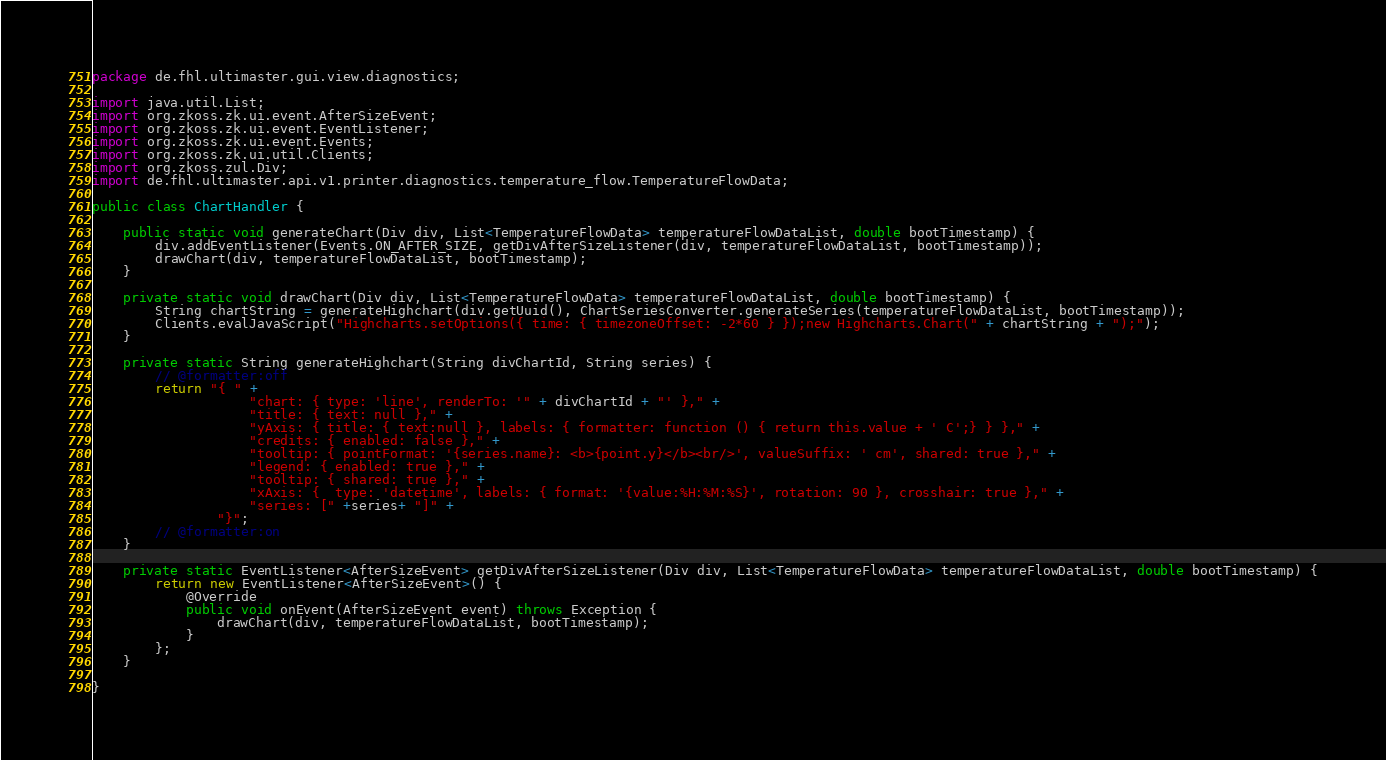Convert code to text. <code><loc_0><loc_0><loc_500><loc_500><_Java_>package de.fhl.ultimaster.gui.view.diagnostics;

import java.util.List;
import org.zkoss.zk.ui.event.AfterSizeEvent;
import org.zkoss.zk.ui.event.EventListener;
import org.zkoss.zk.ui.event.Events;
import org.zkoss.zk.ui.util.Clients;
import org.zkoss.zul.Div;
import de.fhl.ultimaster.api.v1.printer.diagnostics.temperature_flow.TemperatureFlowData;

public class ChartHandler {

    public static void generateChart(Div div, List<TemperatureFlowData> temperatureFlowDataList, double bootTimestamp) {
        div.addEventListener(Events.ON_AFTER_SIZE, getDivAfterSizeListener(div, temperatureFlowDataList, bootTimestamp));
        drawChart(div, temperatureFlowDataList, bootTimestamp);
    }

    private static void drawChart(Div div, List<TemperatureFlowData> temperatureFlowDataList, double bootTimestamp) {
        String chartString = generateHighchart(div.getUuid(), ChartSeriesConverter.generateSeries(temperatureFlowDataList, bootTimestamp));
        Clients.evalJavaScript("Highcharts.setOptions({ time: { timezoneOffset: -2*60 } });new Highcharts.Chart(" + chartString + ");");
    }

    private static String generateHighchart(String divChartId, String series) {
        // @formatter:off
        return "{ " +
                    "chart: { type: 'line', renderTo: '" + divChartId + "' }," +
                    "title: { text: null }," +
                    "yAxis: { title: { text:null }, labels: { formatter: function () { return this.value + ' C';} } }," +
                    "credits: { enabled: false }," +
                    "tooltip: { pointFormat: '{series.name}: <b>{point.y}</b><br/>', valueSuffix: ' cm', shared: true }," +
                    "legend: { enabled: true }," +
                    "tooltip: { shared: true }," +
                    "xAxis: {  type: 'datetime', labels: { format: '{value:%H:%M:%S}', rotation: 90 }, crosshair: true }," +
                    "series: [" +series+ "]" +
                "}";
        // @formatter:on
    }

    private static EventListener<AfterSizeEvent> getDivAfterSizeListener(Div div, List<TemperatureFlowData> temperatureFlowDataList, double bootTimestamp) {
        return new EventListener<AfterSizeEvent>() {
            @Override
            public void onEvent(AfterSizeEvent event) throws Exception {
                drawChart(div, temperatureFlowDataList, bootTimestamp);
            }
        };
    }

}
</code> 